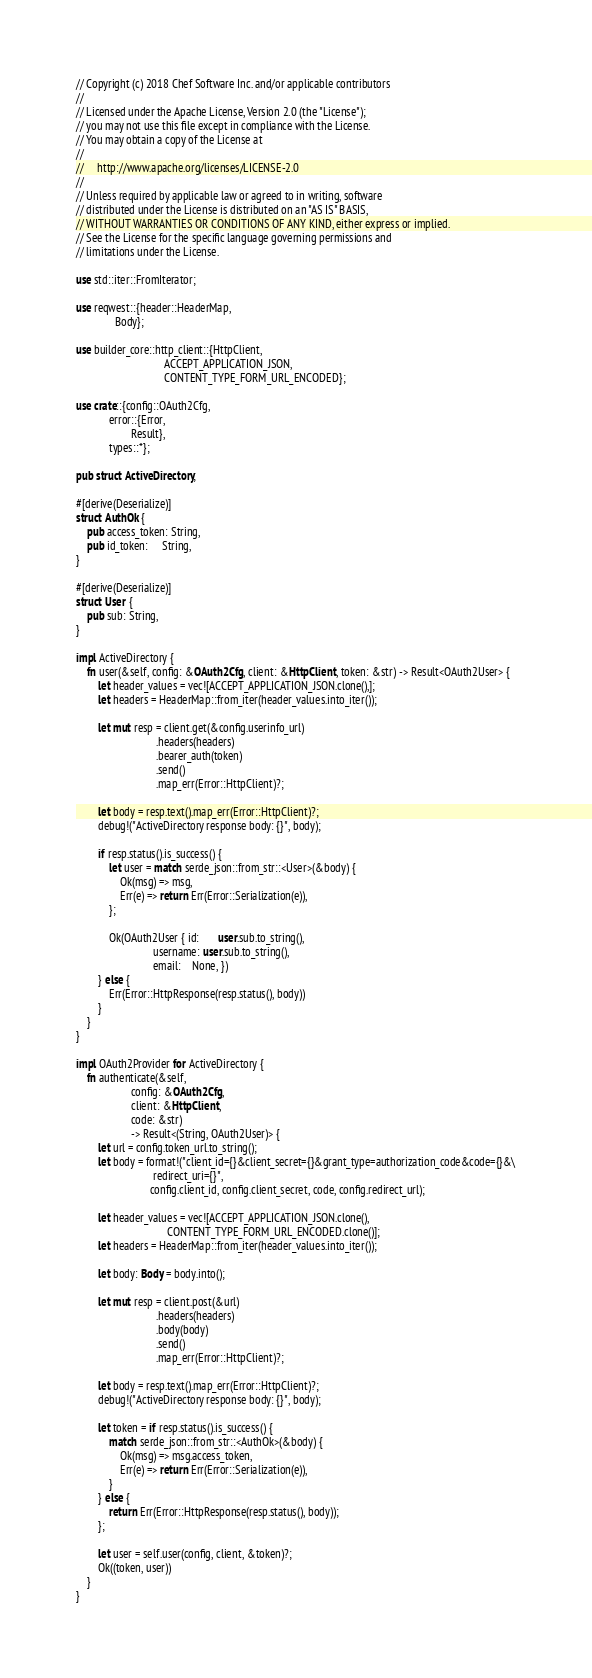<code> <loc_0><loc_0><loc_500><loc_500><_Rust_>// Copyright (c) 2018 Chef Software Inc. and/or applicable contributors
//
// Licensed under the Apache License, Version 2.0 (the "License");
// you may not use this file except in compliance with the License.
// You may obtain a copy of the License at
//
//     http://www.apache.org/licenses/LICENSE-2.0
//
// Unless required by applicable law or agreed to in writing, software
// distributed under the License is distributed on an "AS IS" BASIS,
// WITHOUT WARRANTIES OR CONDITIONS OF ANY KIND, either express or implied.
// See the License for the specific language governing permissions and
// limitations under the License.

use std::iter::FromIterator;

use reqwest::{header::HeaderMap,
              Body};

use builder_core::http_client::{HttpClient,
                                ACCEPT_APPLICATION_JSON,
                                CONTENT_TYPE_FORM_URL_ENCODED};

use crate::{config::OAuth2Cfg,
            error::{Error,
                    Result},
            types::*};

pub struct ActiveDirectory;

#[derive(Deserialize)]
struct AuthOk {
    pub access_token: String,
    pub id_token:     String,
}

#[derive(Deserialize)]
struct User {
    pub sub: String,
}

impl ActiveDirectory {
    fn user(&self, config: &OAuth2Cfg, client: &HttpClient, token: &str) -> Result<OAuth2User> {
        let header_values = vec![ACCEPT_APPLICATION_JSON.clone(),];
        let headers = HeaderMap::from_iter(header_values.into_iter());

        let mut resp = client.get(&config.userinfo_url)
                             .headers(headers)
                             .bearer_auth(token)
                             .send()
                             .map_err(Error::HttpClient)?;

        let body = resp.text().map_err(Error::HttpClient)?;
        debug!("ActiveDirectory response body: {}", body);

        if resp.status().is_success() {
            let user = match serde_json::from_str::<User>(&body) {
                Ok(msg) => msg,
                Err(e) => return Err(Error::Serialization(e)),
            };

            Ok(OAuth2User { id:       user.sub.to_string(),
                            username: user.sub.to_string(),
                            email:    None, })
        } else {
            Err(Error::HttpResponse(resp.status(), body))
        }
    }
}

impl OAuth2Provider for ActiveDirectory {
    fn authenticate(&self,
                    config: &OAuth2Cfg,
                    client: &HttpClient,
                    code: &str)
                    -> Result<(String, OAuth2User)> {
        let url = config.token_url.to_string();
        let body = format!("client_id={}&client_secret={}&grant_type=authorization_code&code={}&\
                            redirect_uri={}",
                           config.client_id, config.client_secret, code, config.redirect_url);

        let header_values = vec![ACCEPT_APPLICATION_JSON.clone(),
                                 CONTENT_TYPE_FORM_URL_ENCODED.clone()];
        let headers = HeaderMap::from_iter(header_values.into_iter());

        let body: Body = body.into();

        let mut resp = client.post(&url)
                             .headers(headers)
                             .body(body)
                             .send()
                             .map_err(Error::HttpClient)?;

        let body = resp.text().map_err(Error::HttpClient)?;
        debug!("ActiveDirectory response body: {}", body);

        let token = if resp.status().is_success() {
            match serde_json::from_str::<AuthOk>(&body) {
                Ok(msg) => msg.access_token,
                Err(e) => return Err(Error::Serialization(e)),
            }
        } else {
            return Err(Error::HttpResponse(resp.status(), body));
        };

        let user = self.user(config, client, &token)?;
        Ok((token, user))
    }
}
</code> 